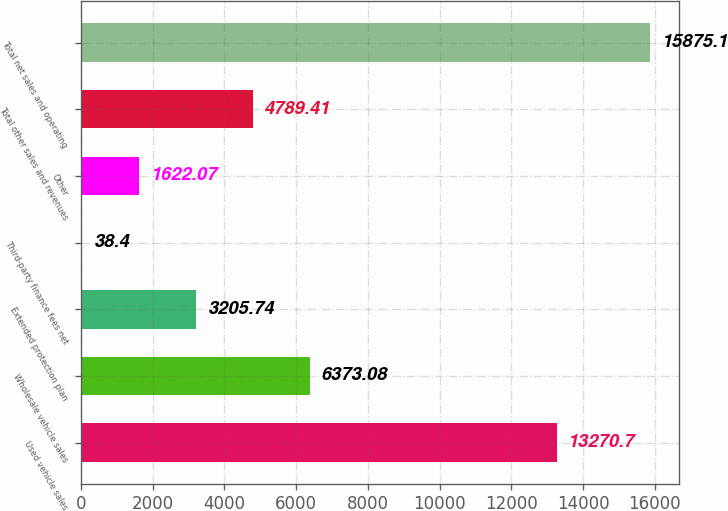<chart> <loc_0><loc_0><loc_500><loc_500><bar_chart><fcel>Used vehicle sales<fcel>Wholesale vehicle sales<fcel>Extended protection plan<fcel>Third-party finance fees net<fcel>Other<fcel>Total other sales and revenues<fcel>Total net sales and operating<nl><fcel>13270.7<fcel>6373.08<fcel>3205.74<fcel>38.4<fcel>1622.07<fcel>4789.41<fcel>15875.1<nl></chart> 